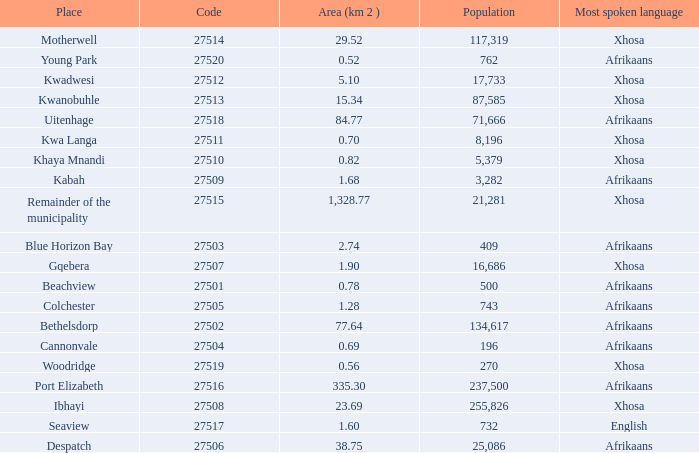Can you give me this table as a dict? {'header': ['Place', 'Code', 'Area (km 2 )', 'Population', 'Most spoken language'], 'rows': [['Motherwell', '27514', '29.52', '117,319', 'Xhosa'], ['Young Park', '27520', '0.52', '762', 'Afrikaans'], ['Kwadwesi', '27512', '5.10', '17,733', 'Xhosa'], ['Kwanobuhle', '27513', '15.34', '87,585', 'Xhosa'], ['Uitenhage', '27518', '84.77', '71,666', 'Afrikaans'], ['Kwa Langa', '27511', '0.70', '8,196', 'Xhosa'], ['Khaya Mnandi', '27510', '0.82', '5,379', 'Xhosa'], ['Kabah', '27509', '1.68', '3,282', 'Afrikaans'], ['Remainder of the municipality', '27515', '1,328.77', '21,281', 'Xhosa'], ['Blue Horizon Bay', '27503', '2.74', '409', 'Afrikaans'], ['Gqebera', '27507', '1.90', '16,686', 'Xhosa'], ['Beachview', '27501', '0.78', '500', 'Afrikaans'], ['Colchester', '27505', '1.28', '743', 'Afrikaans'], ['Bethelsdorp', '27502', '77.64', '134,617', 'Afrikaans'], ['Cannonvale', '27504', '0.69', '196', 'Afrikaans'], ['Woodridge', '27519', '0.56', '270', 'Xhosa'], ['Port Elizabeth', '27516', '335.30', '237,500', 'Afrikaans'], ['Ibhayi', '27508', '23.69', '255,826', 'Xhosa'], ['Seaview', '27517', '1.60', '732', 'English'], ['Despatch', '27506', '38.75', '25,086', 'Afrikaans']]} What is the place that speaks xhosa, has a population less than 87,585, an area smaller than 1.28 squared kilometers, and a code larger than 27504? Khaya Mnandi, Kwa Langa, Woodridge. 